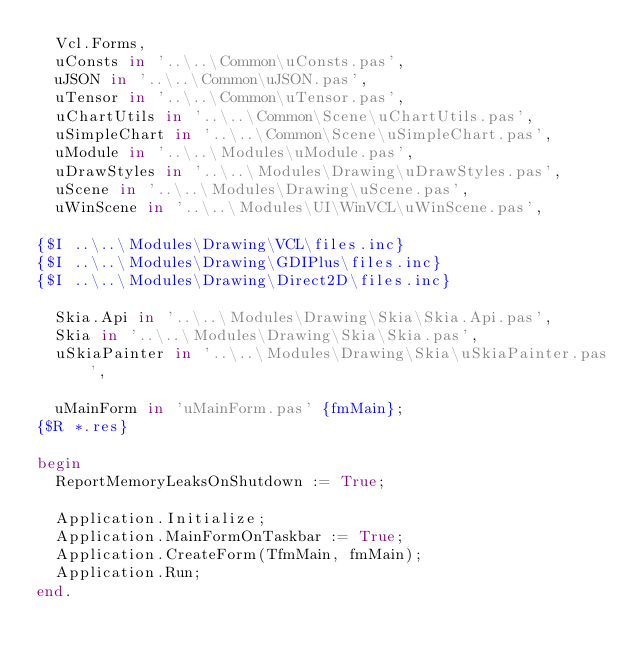Convert code to text. <code><loc_0><loc_0><loc_500><loc_500><_Pascal_>  Vcl.Forms,
  uConsts in '..\..\Common\uConsts.pas',
  uJSON in '..\..\Common\uJSON.pas',
  uTensor in '..\..\Common\uTensor.pas',
  uChartUtils in '..\..\Common\Scene\uChartUtils.pas',
  uSimpleChart in '..\..\Common\Scene\uSimpleChart.pas',
  uModule in '..\..\Modules\uModule.pas',
  uDrawStyles in '..\..\Modules\Drawing\uDrawStyles.pas',
  uScene in '..\..\Modules\Drawing\uScene.pas',
  uWinScene in '..\..\Modules\UI\WinVCL\uWinScene.pas',

{$I ..\..\Modules\Drawing\VCL\files.inc}
{$I ..\..\Modules\Drawing\GDIPlus\files.inc}
{$I ..\..\Modules\Drawing\Direct2D\files.inc}

  Skia.Api in '..\..\Modules\Drawing\Skia\Skia.Api.pas',
  Skia in '..\..\Modules\Drawing\Skia\Skia.pas',
  uSkiaPainter in '..\..\Modules\Drawing\Skia\uSkiaPainter.pas',

  uMainForm in 'uMainForm.pas' {fmMain};
{$R *.res}

begin
  ReportMemoryLeaksOnShutdown := True;

  Application.Initialize;
  Application.MainFormOnTaskbar := True;
  Application.CreateForm(TfmMain, fmMain);
  Application.Run;
end.
</code> 